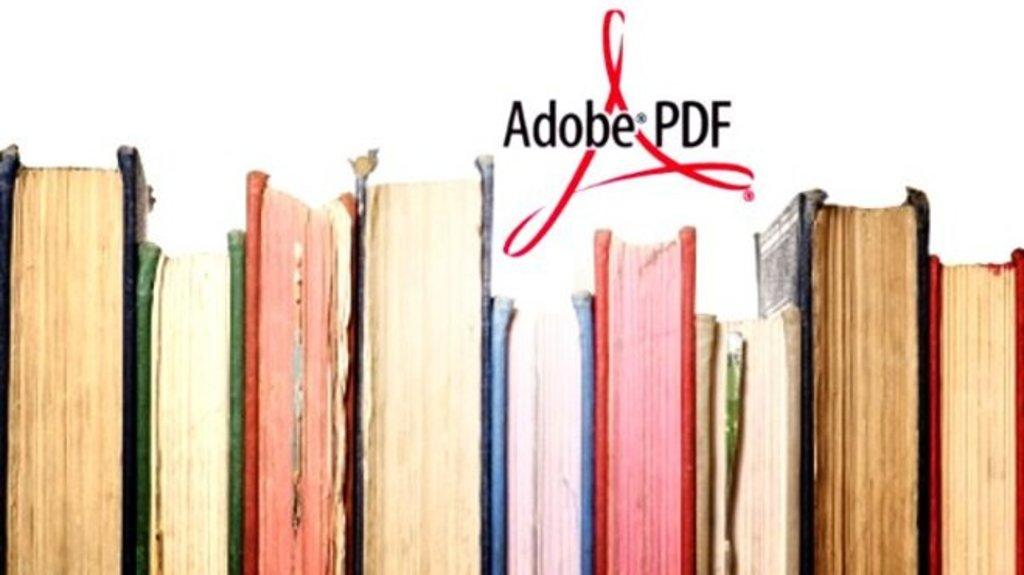Provide a one-sentence caption for the provided image. An advertisement for Adobe PDF that includes the logo and a lineup of old books. 